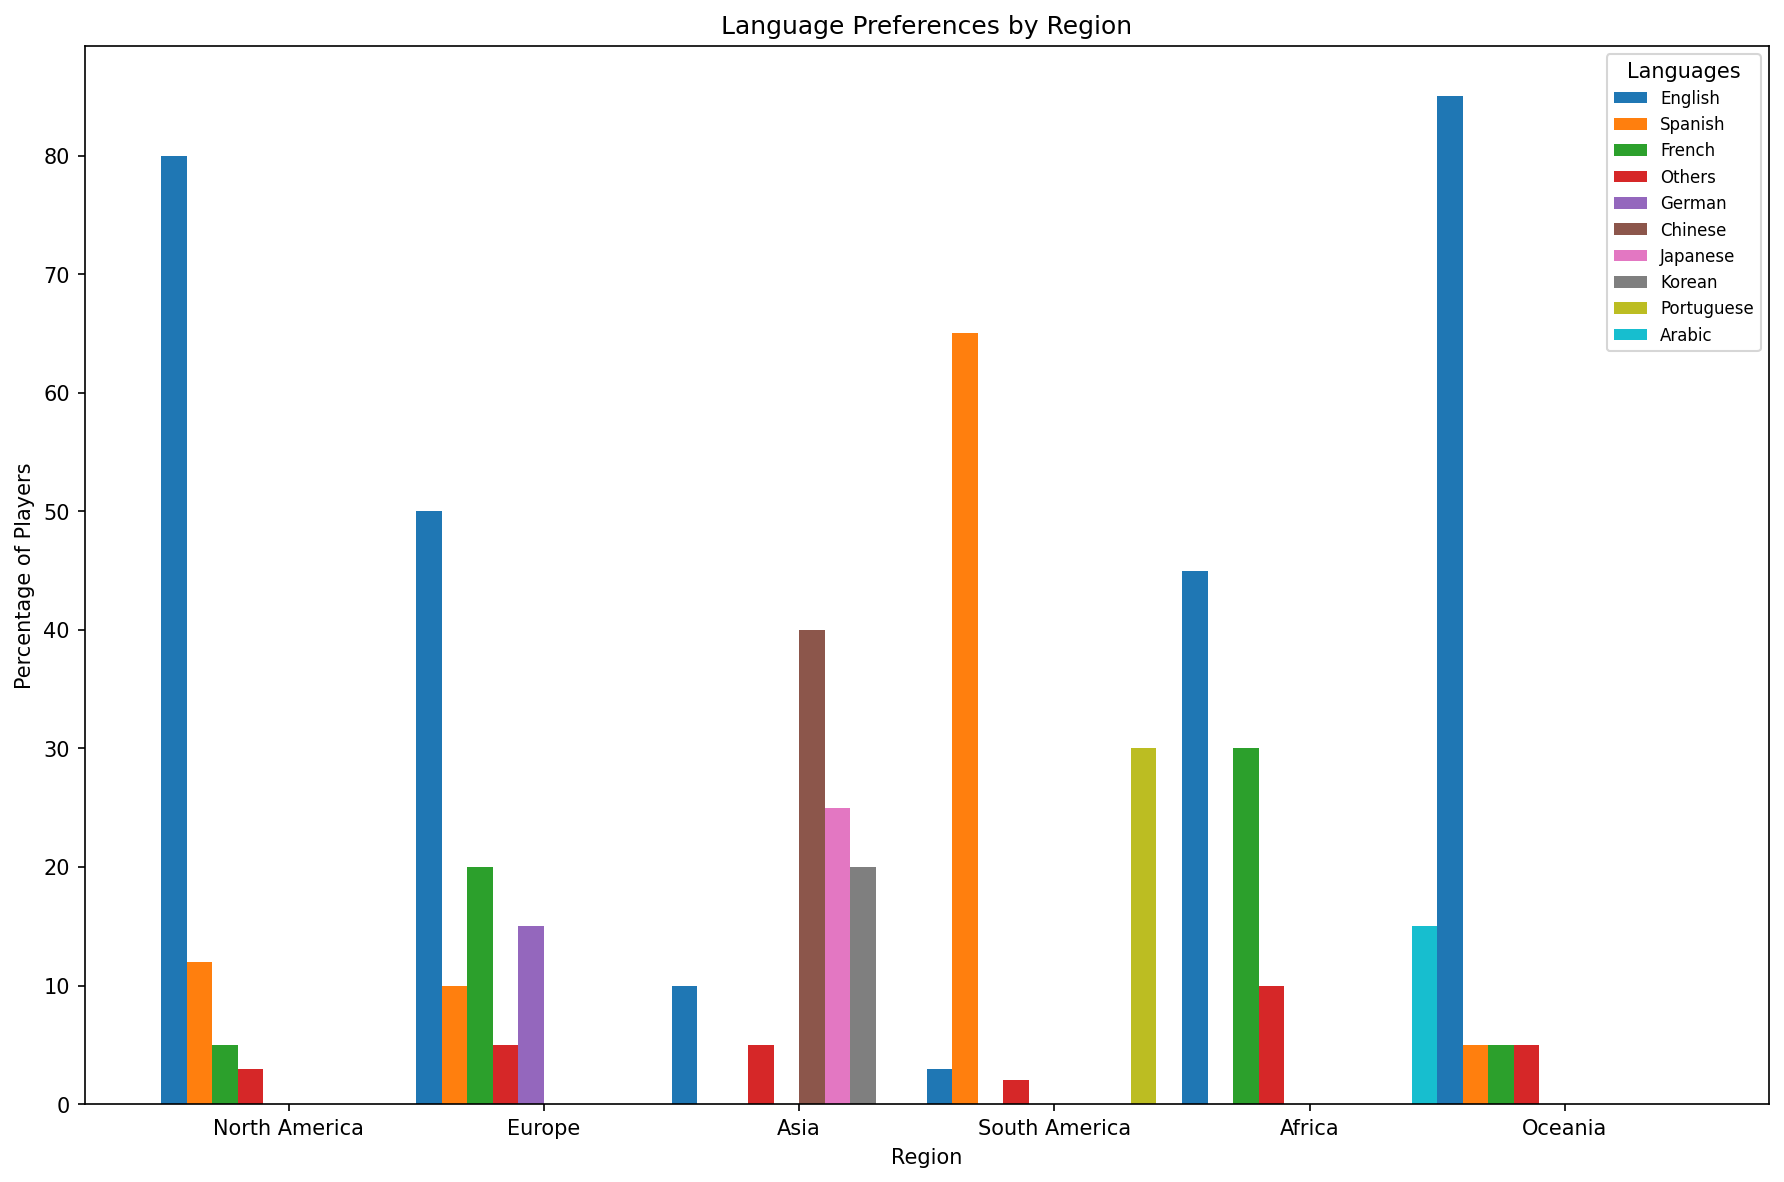Which region has the highest percentage of players preferring English? In the bar chart, identify the highest bar for English in different regions. The tallest bar for English is in Oceania.
Answer: Oceania Which language is most preferred in South America? Look at the bars for each language in South America. The bar representing Spanish is the tallest.
Answer: Spanish Compare the percentage of players preferring French in Europe with those in Africa. Which region has a higher percentage? Check the height of the French bar in Europe and Africa. In Europe, French is 20%, and in Africa, it's 30%.
Answer: Africa What is the combined percentage of players preferring English and Spanish in North America? Find the bars for English and Spanish in North America. English is 80%, and Spanish is 12%. Add these two values (80 + 12).
Answer: 92 How does the percentage of French-speaking players in North America compare to Europe? Check the French bar heights in North America and Europe. In North America, French is 5%, and in Europe, it's 20%.
Answer: Europe What proportion of players in Africa prefer languages other than English and French altogether? Identify the bars in Africa for languages other than English and French (Arabic 15%, Others 10%). Add these two values (15 + 10).
Answer: 25% Which region has the highest diversity in language preferences? Look for the region with more evenly distributed bar heights across various languages. Europe has more balanced distribution across English, French, German, Spanish, and Others compared to other regions.
Answer: Europe What is the percentage difference between players preferring Japanese and Korean in Asia? Check the bar heights for Japanese and Korean in Asia. Japanese is 25%, and Korean is 20%. Subtract the two values (25 - 20).
Answer: 5% Which region has the smallest percentage of English-speaking players? Identify the bars for English in all regions and find the shortest bar. The smallest bar is in South America at 3%.
Answer: South America What is the total percentage of players preferring Japanese and Chinese in Asia? Find the bars for Japanese (25%) and Chinese (40%) in Asia. Add these two values (25 + 40).
Answer: 65 